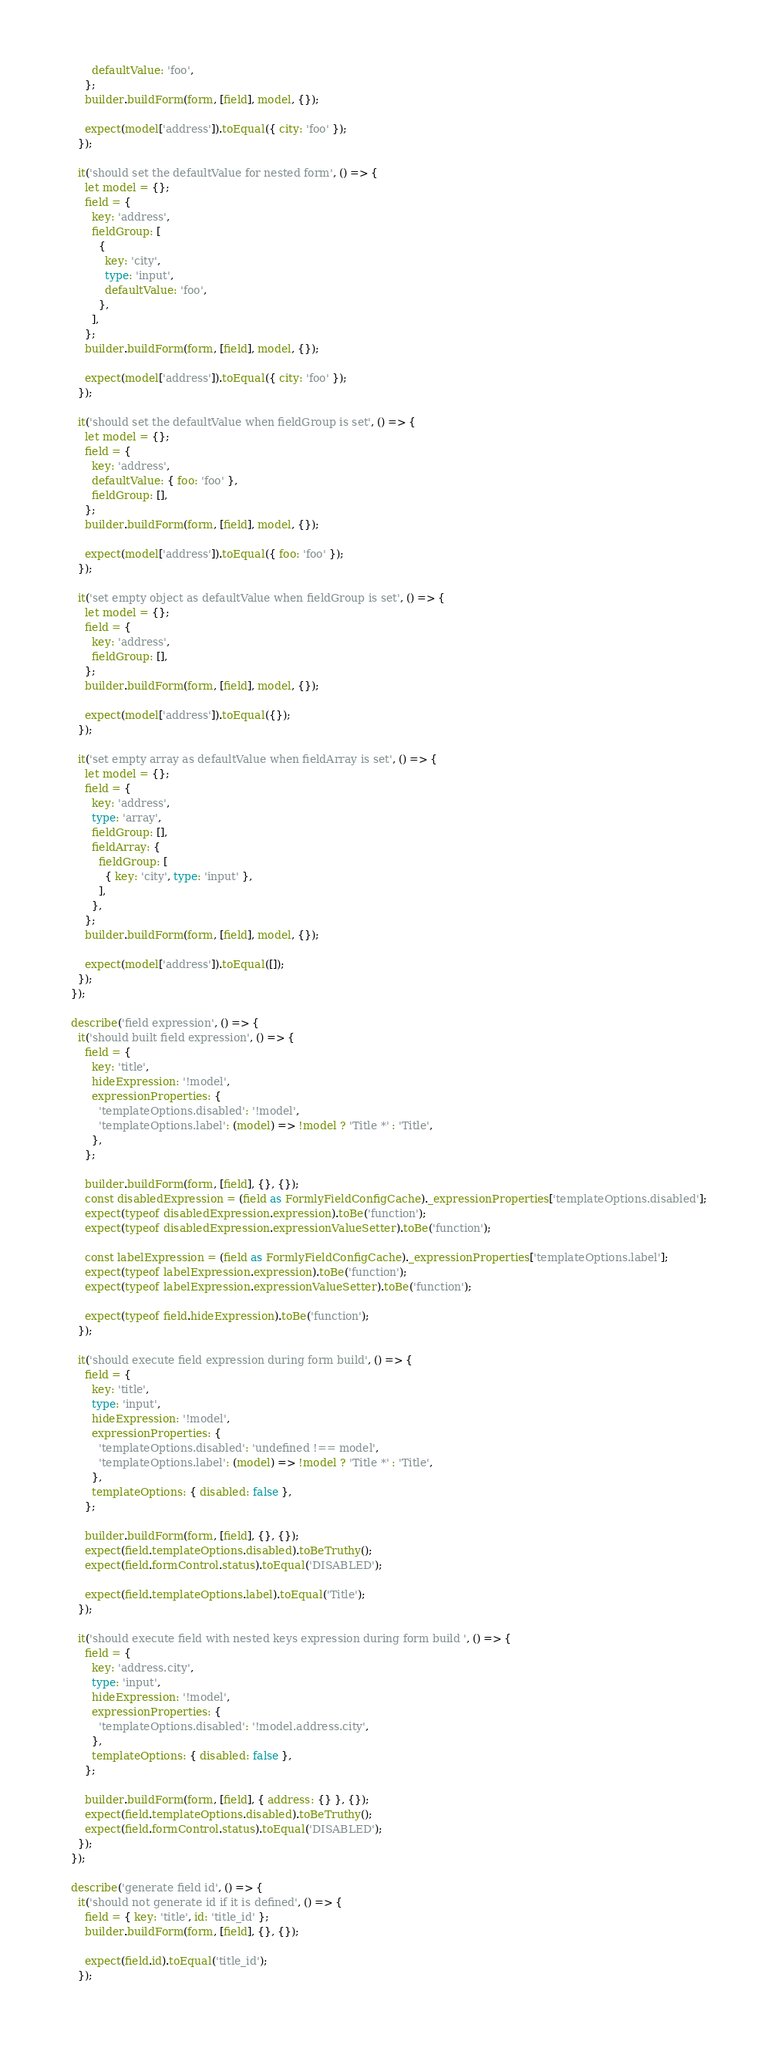<code> <loc_0><loc_0><loc_500><loc_500><_TypeScript_>        defaultValue: 'foo',
      };
      builder.buildForm(form, [field], model, {});

      expect(model['address']).toEqual({ city: 'foo' });
    });

    it('should set the defaultValue for nested form', () => {
      let model = {};
      field = {
        key: 'address',
        fieldGroup: [
          {
            key: 'city',
            type: 'input',
            defaultValue: 'foo',
          },
        ],
      };
      builder.buildForm(form, [field], model, {});

      expect(model['address']).toEqual({ city: 'foo' });
    });

    it('should set the defaultValue when fieldGroup is set', () => {
      let model = {};
      field = {
        key: 'address',
        defaultValue: { foo: 'foo' },
        fieldGroup: [],
      };
      builder.buildForm(form, [field], model, {});

      expect(model['address']).toEqual({ foo: 'foo' });
    });

    it('set empty object as defaultValue when fieldGroup is set', () => {
      let model = {};
      field = {
        key: 'address',
        fieldGroup: [],
      };
      builder.buildForm(form, [field], model, {});

      expect(model['address']).toEqual({});
    });

    it('set empty array as defaultValue when fieldArray is set', () => {
      let model = {};
      field = {
        key: 'address',
        type: 'array',
        fieldGroup: [],
        fieldArray: {
          fieldGroup: [
            { key: 'city', type: 'input' },
          ],
        },
      };
      builder.buildForm(form, [field], model, {});

      expect(model['address']).toEqual([]);
    });
  });

  describe('field expression', () => {
    it('should built field expression', () => {
      field = {
        key: 'title',
        hideExpression: '!model',
        expressionProperties: {
          'templateOptions.disabled': '!model',
          'templateOptions.label': (model) => !model ? 'Title *' : 'Title',
        },
      };

      builder.buildForm(form, [field], {}, {});
      const disabledExpression = (field as FormlyFieldConfigCache)._expressionProperties['templateOptions.disabled'];
      expect(typeof disabledExpression.expression).toBe('function');
      expect(typeof disabledExpression.expressionValueSetter).toBe('function');

      const labelExpression = (field as FormlyFieldConfigCache)._expressionProperties['templateOptions.label'];
      expect(typeof labelExpression.expression).toBe('function');
      expect(typeof labelExpression.expressionValueSetter).toBe('function');

      expect(typeof field.hideExpression).toBe('function');
    });

    it('should execute field expression during form build', () => {
      field = {
        key: 'title',
        type: 'input',
        hideExpression: '!model',
        expressionProperties: {
          'templateOptions.disabled': 'undefined !== model',
          'templateOptions.label': (model) => !model ? 'Title *' : 'Title',
        },
        templateOptions: { disabled: false },
      };

      builder.buildForm(form, [field], {}, {});
      expect(field.templateOptions.disabled).toBeTruthy();
      expect(field.formControl.status).toEqual('DISABLED');

      expect(field.templateOptions.label).toEqual('Title');
    });

    it('should execute field with nested keys expression during form build ', () => {
      field = {
        key: 'address.city',
        type: 'input',
        hideExpression: '!model',
        expressionProperties: {
          'templateOptions.disabled': '!model.address.city',
        },
        templateOptions: { disabled: false },
      };

      builder.buildForm(form, [field], { address: {} }, {});
      expect(field.templateOptions.disabled).toBeTruthy();
      expect(field.formControl.status).toEqual('DISABLED');
    });
  });

  describe('generate field id', () => {
    it('should not generate id if it is defined', () => {
      field = { key: 'title', id: 'title_id' };
      builder.buildForm(form, [field], {}, {});

      expect(field.id).toEqual('title_id');
    });
</code> 